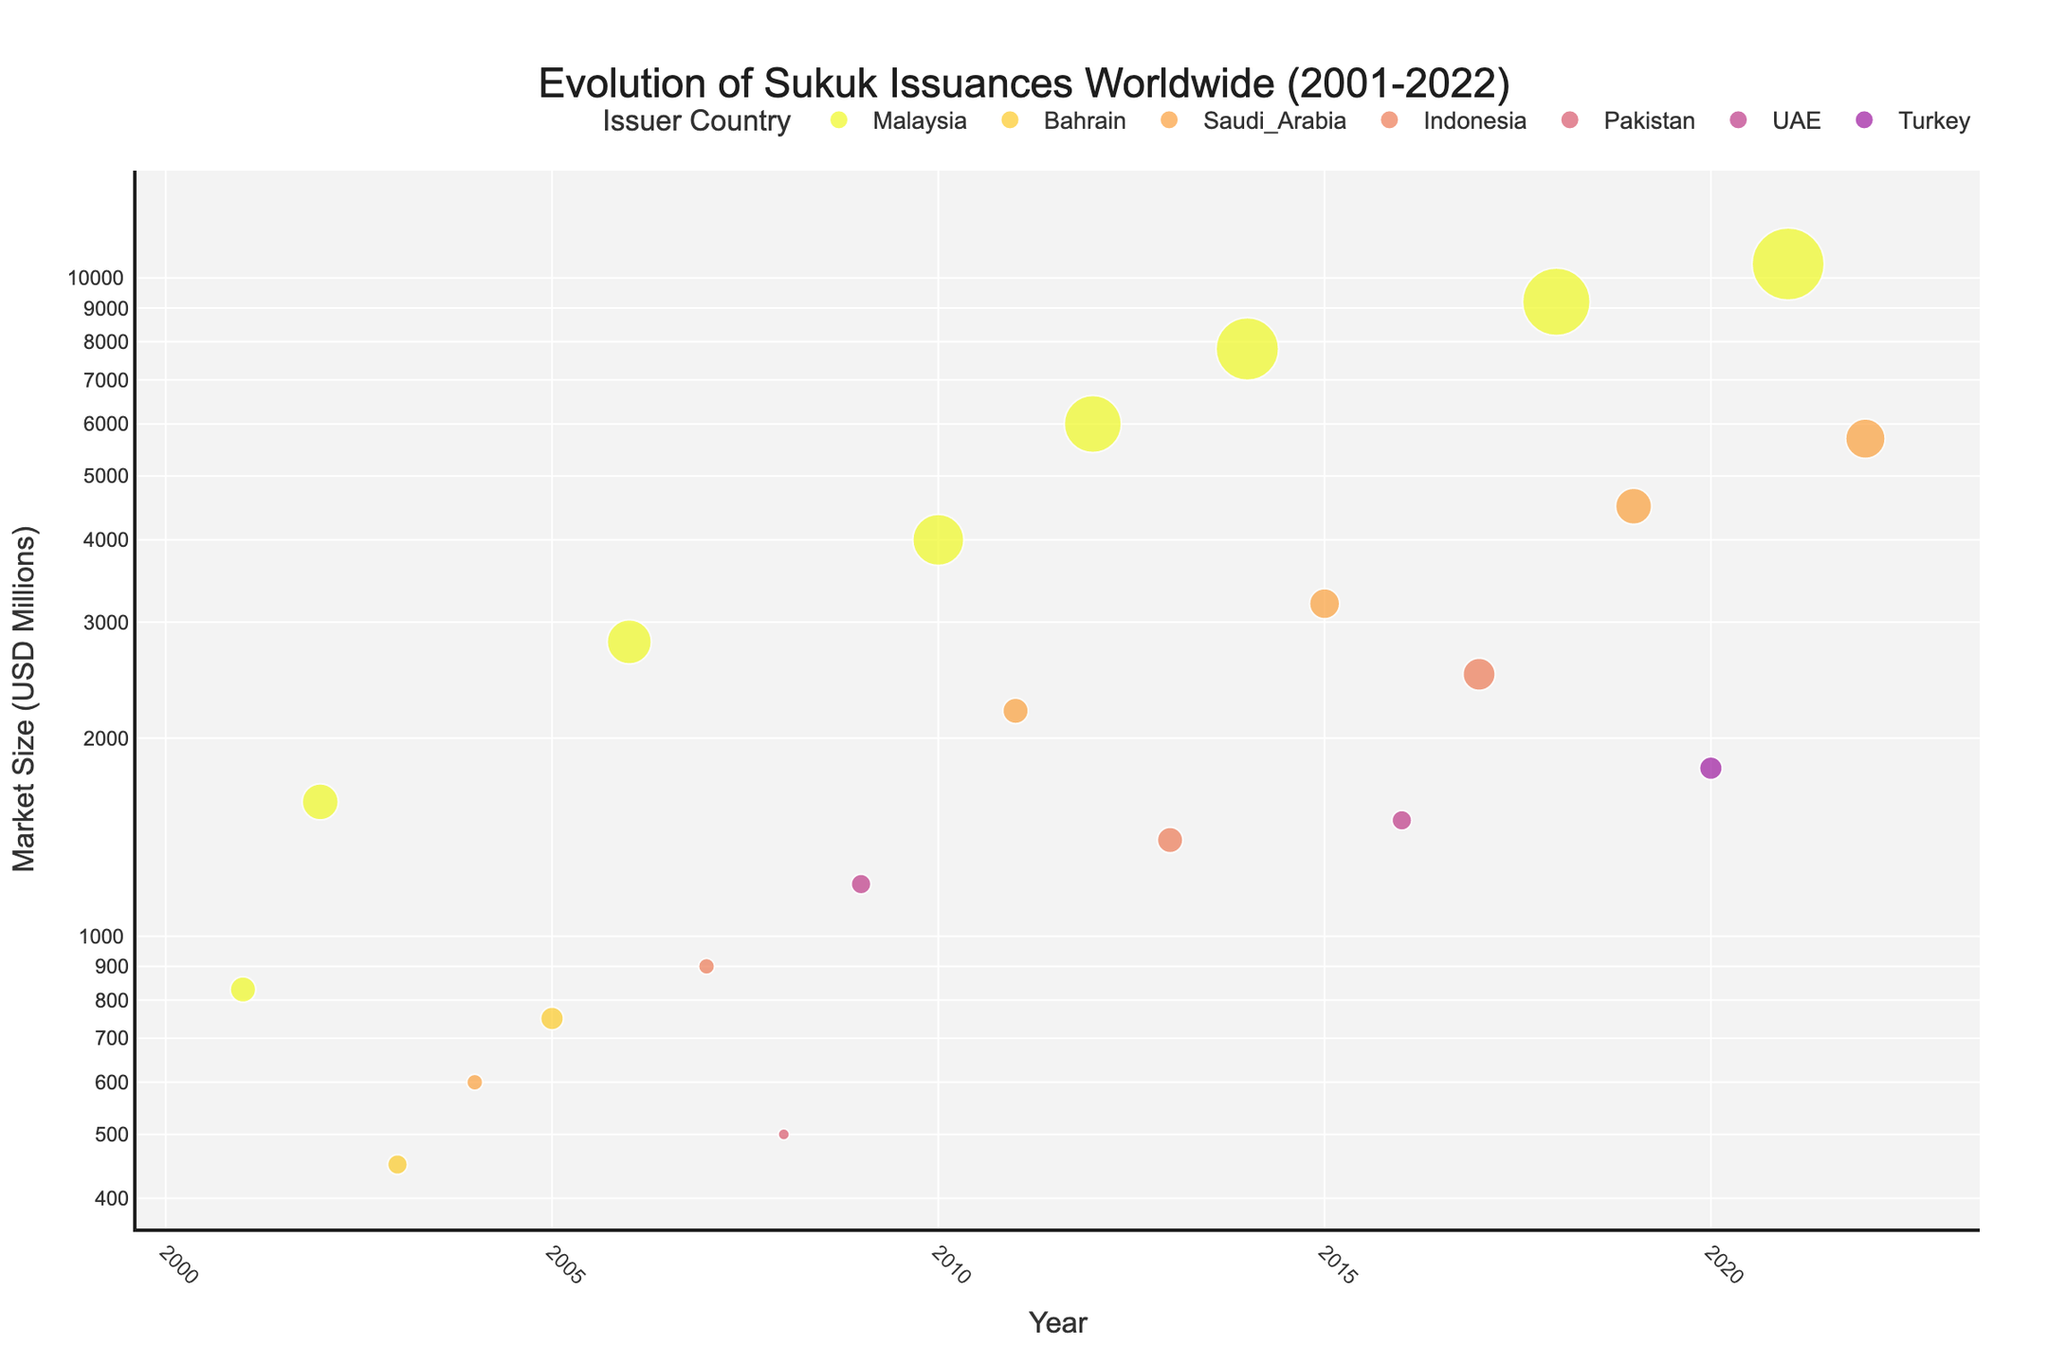What is the title of the plot? The title is prominently displayed at the top of the plot. In this case, it reads "Evolution of Sukuk Issuances Worldwide (2001-2022)".
Answer: Evolution of Sukuk Issuances Worldwide (2001-2022) What do the bubble sizes represent? The legend, which is usually located on the plot, indicates what each visual element represents. The size of the bubbles represents the 'Number of Sukuk Issuances'.
Answer: Number of Sukuk Issuances Which country had the highest number of Sukuk issuances in 2022? By finding the data point for the year 2022 and looking at the sizes of the bubbles, we can see the largest bubble represents Saudi Arabia.
Answer: Saudi Arabia In which year did Malaysia have the highest market size? By locating the bubbles representing Malaysia across the years and observing their position on the y-axis, Malaysia had the highest market size in 2021 with a market size of $10,500 million.
Answer: 2021 Compare the market size and number of issuances between Malaysia in 2015 and Saudi Arabia in 2022. Look for the bubbles corresponding to Malaysia in 2015 and Saudi Arabia in 2022. Malaysia in 2015 has a smaller bubble size (7 issuances) and lower market size (3200 million) compared to Saudi Arabia in 2022 (12 issuances and 5700 million)
Answer: Malaysia: 7 issuances, $3200 million; Saudi Arabia: 12 issuances, $5700 million Which country had the first issuance of Sukuk based on the plot? By observing the x-axis and finding the leftmost bubble, the first issuance was by Malaysia in 2001.
Answer: Malaysia How did the market size for Sukuk issuances in Indonesia evolve from 2007 to 2017? Locate the data points for Indonesia in 2007 and 2017. In 2007, the market size was $900 million, and in 2017, it increased to $2500 million, indicating a significant rise.
Answer: Increased from $900 million to $2500 million What is the visible trend in the number of issuances in Malaysia from 2001 to 2022? Looking at the size of the bubbles representing Malaysia over the years, there is a consistent increase in the number of issuances from 5 in 2001 to 40 in 2021, showing a clear upward trend.
Answer: Upward trend Identify two years with the same number of issuances but different market sizes for Saudi Arabia. Find the bubbles representing Saudi Arabia and compare the years. In 2004 and 2011, Saudi Arabia had 2 issuances, but the market sizes were $600 million and $2200 million, respectively.
Answer: 2004 and 2011 What pattern can be observed in the log scale of the y-axis in terms of market sizes? The log scale allows us to see multiplicative changes rather than additive, so smaller movements on the scale represent larger actual differences in million USD; the market sizes grow exponentially over time.
Answer: Exponential growth trajectory 